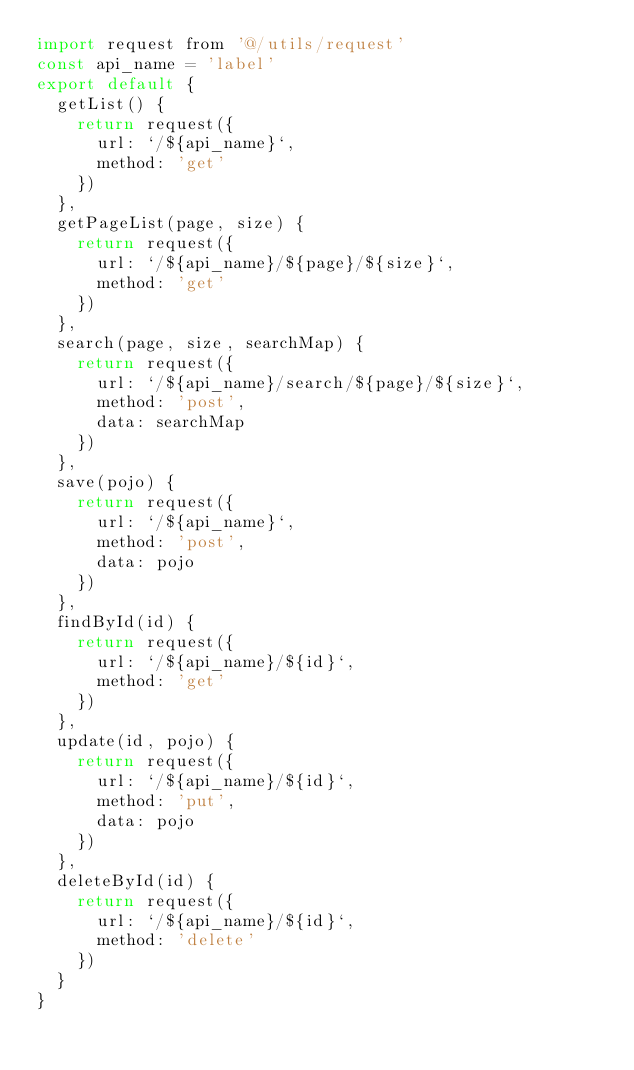<code> <loc_0><loc_0><loc_500><loc_500><_JavaScript_>import request from '@/utils/request'
const api_name = 'label'
export default {
  getList() {
    return request({
      url: `/${api_name}`,
      method: 'get'
    })
  },
  getPageList(page, size) {
    return request({
      url: `/${api_name}/${page}/${size}`,
      method: 'get'
    })
  },
  search(page, size, searchMap) {
    return request({
      url: `/${api_name}/search/${page}/${size}`,
      method: 'post',
      data: searchMap
    })
  },
  save(pojo) {
    return request({
      url: `/${api_name}`,
      method: 'post',
      data: pojo
    })
  },
  findById(id) {
    return request({
      url: `/${api_name}/${id}`,
      method: 'get'
    })
  },
  update(id, pojo) {
    return request({
      url: `/${api_name}/${id}`,
      method: 'put',
      data: pojo
    })
  },
  deleteById(id) {
    return request({
      url: `/${api_name}/${id}`,
      method: 'delete'
    })
  }
}
</code> 